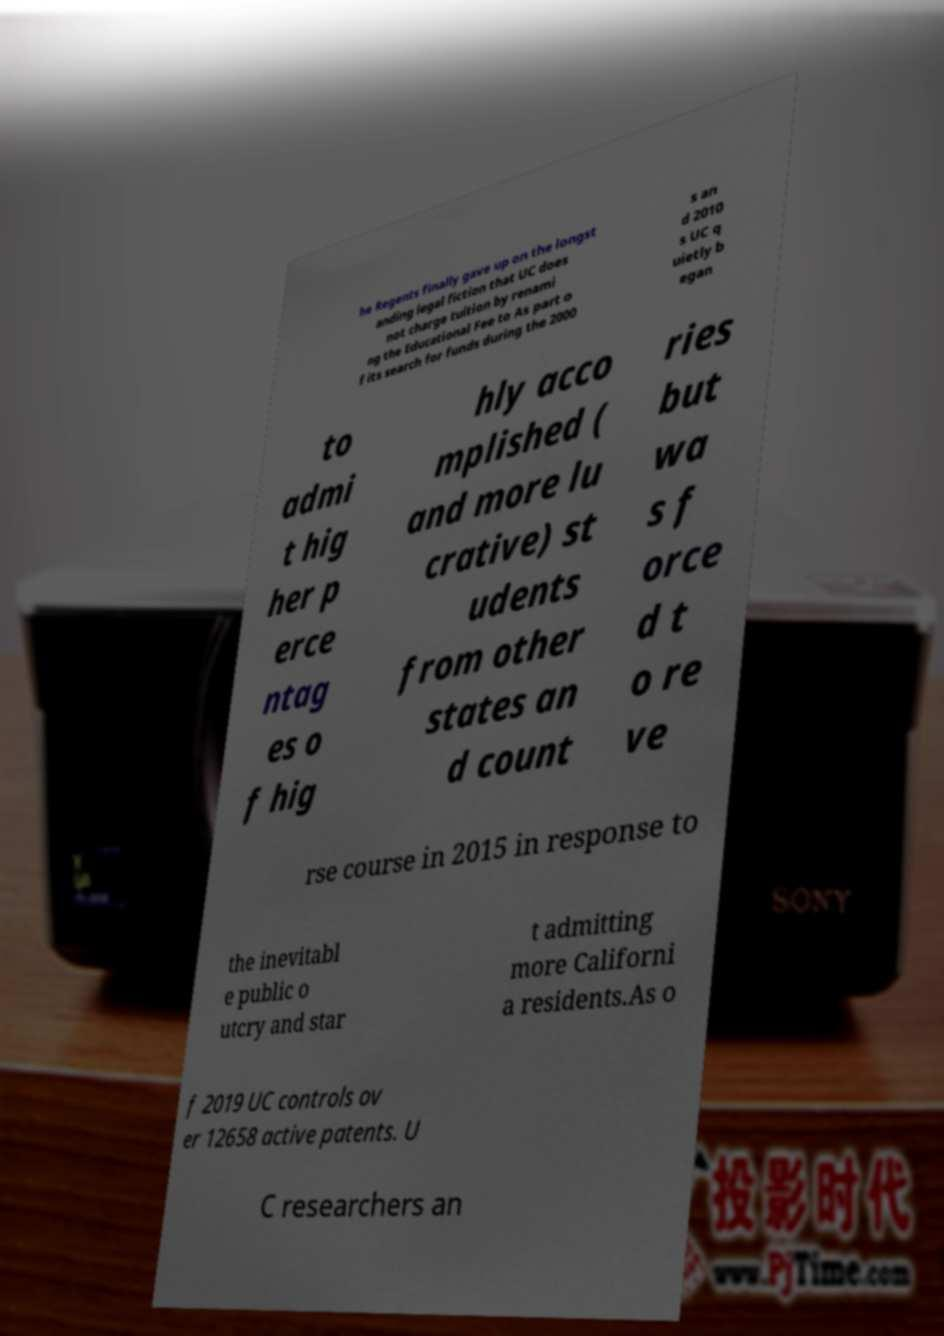There's text embedded in this image that I need extracted. Can you transcribe it verbatim? he Regents finally gave up on the longst anding legal fiction that UC does not charge tuition by renami ng the Educational Fee to As part o f its search for funds during the 2000 s an d 2010 s UC q uietly b egan to admi t hig her p erce ntag es o f hig hly acco mplished ( and more lu crative) st udents from other states an d count ries but wa s f orce d t o re ve rse course in 2015 in response to the inevitabl e public o utcry and star t admitting more Californi a residents.As o f 2019 UC controls ov er 12658 active patents. U C researchers an 